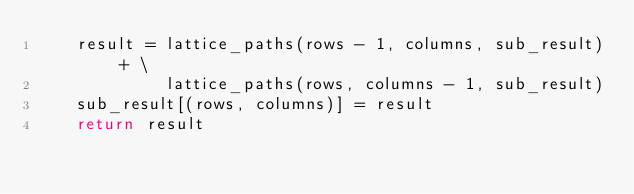<code> <loc_0><loc_0><loc_500><loc_500><_Python_>    result = lattice_paths(rows - 1, columns, sub_result) + \
             lattice_paths(rows, columns - 1, sub_result)
    sub_result[(rows, columns)] = result
    return result</code> 